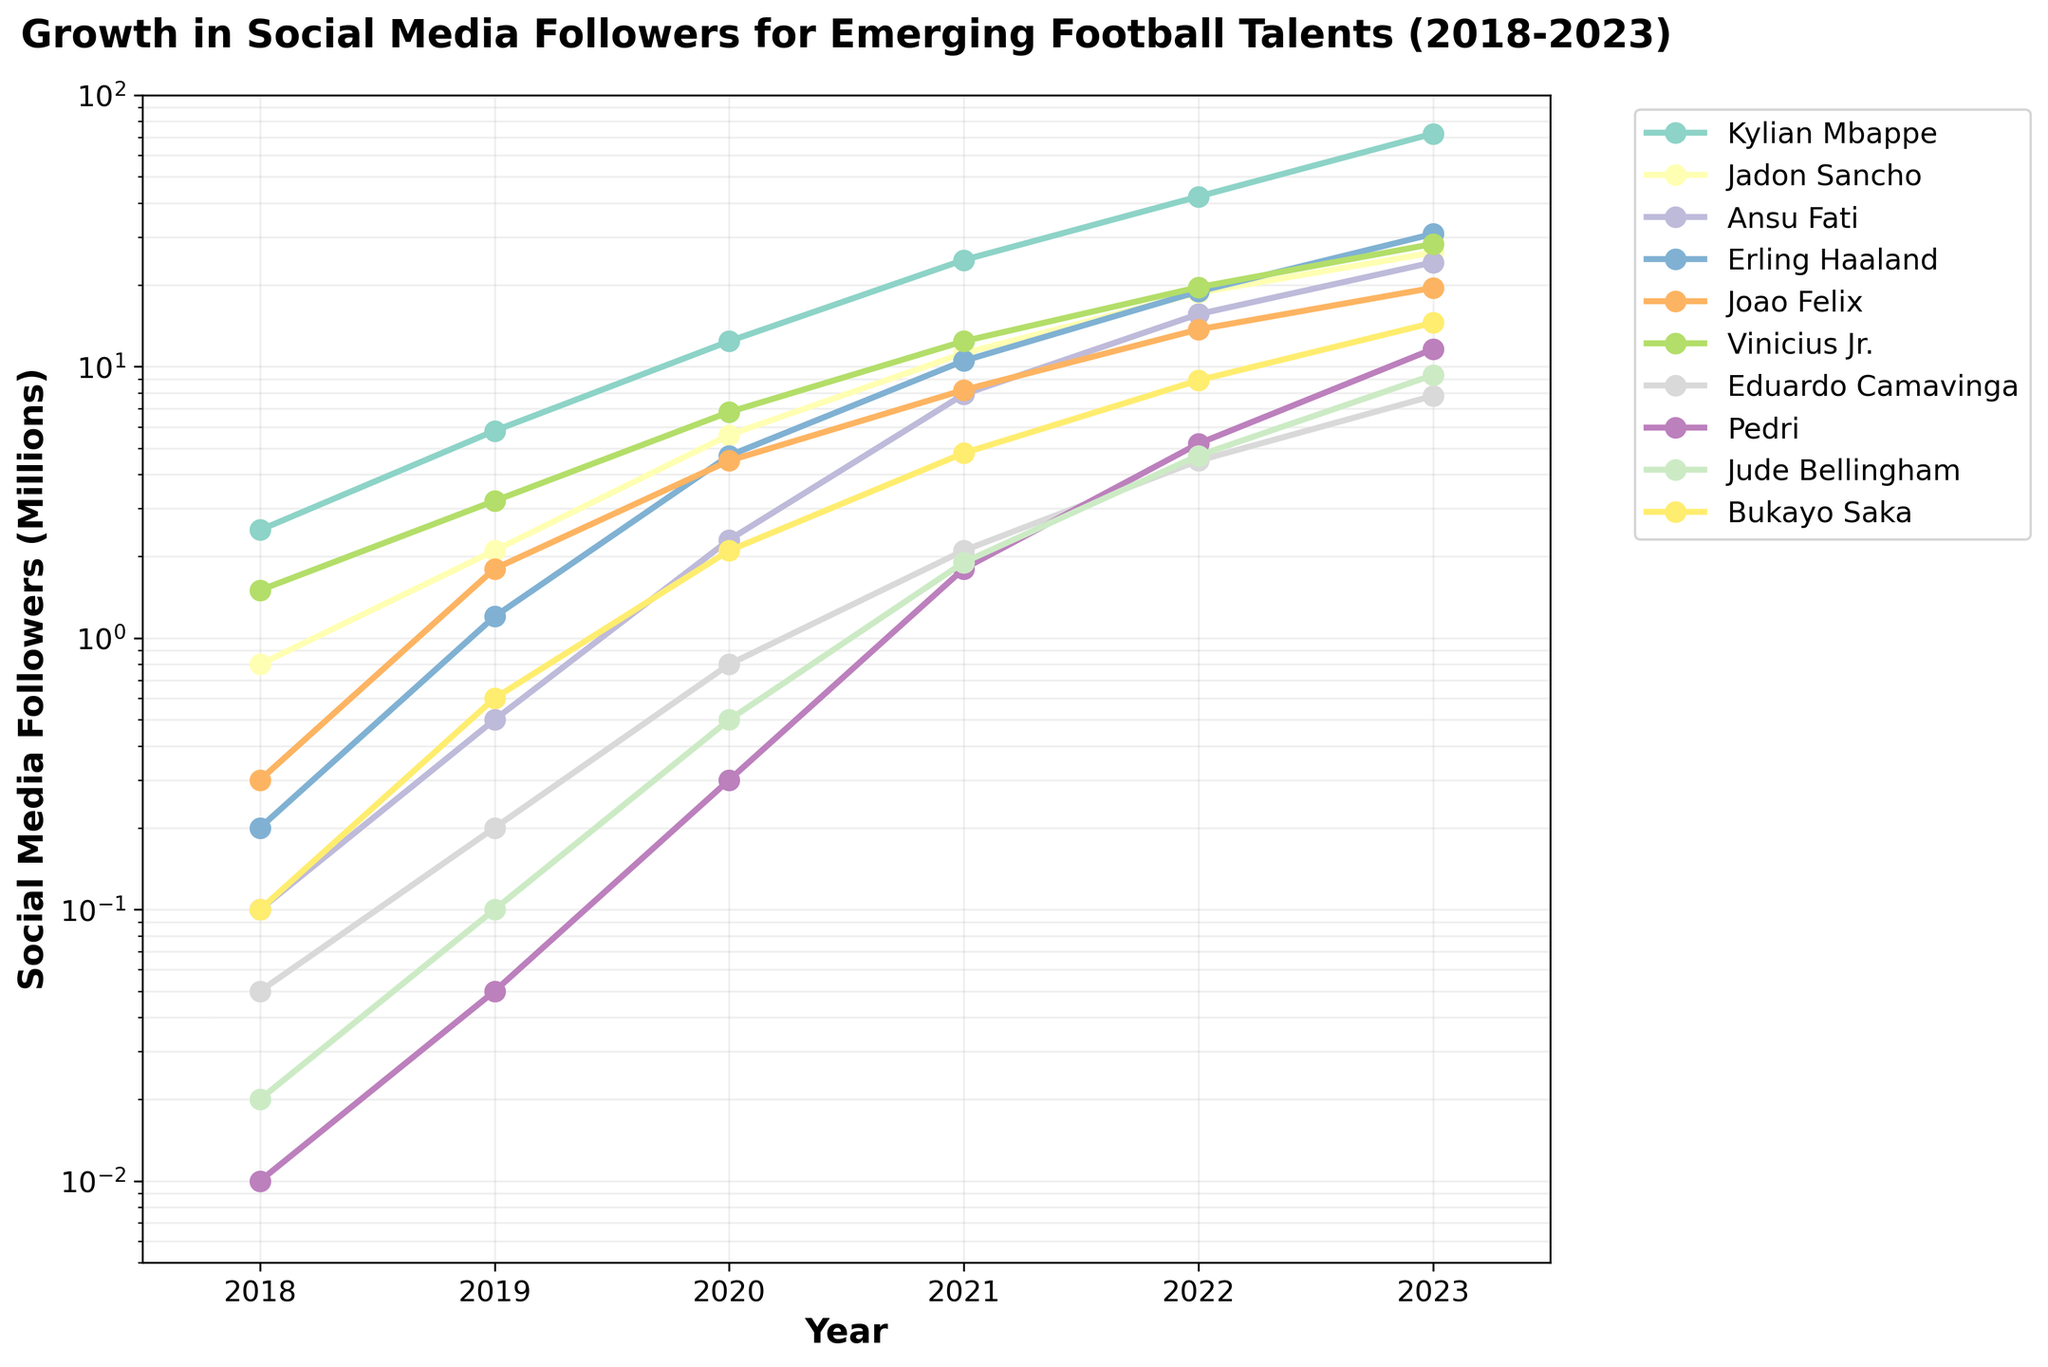What year did Kylian Mbappe's social media followers exceed 10 million? Look at the line for Kylian Mbappe. His followers exceeded 10 million between 2019 and 2020 as the value in 2020 is 12.4 million.
Answer: 2020 Between which two consecutive years did Jadon Sancho's social media followers grow the most? Assess the changes year by year for Jadon Sancho. The largest growth is from 2019 to 2020, rising from 2.1 million to 5.6 million (an increase of 3.5 million).
Answer: 2019-2020 In 2023, did any player other than Kylian Mbappe and Erling Haaland have more than 20 million followers? Check the 2023 values for all players. Only Ansu Fati had more than 20 million followers besides Kylian Mbappe and Erling Haaland.
Answer: Yes What was the total number of social media followers for Vinicius Jr. across all the years in the dataset? Sum the values for Vinicius Jr. from 2018 to 2023: 1.5 + 3.2 + 6.8 + 12.4 + 19.6 + 28.3 = 71.8 million.
Answer: 71.8 million How many players had their social media followers grow by more than 5 million from 2022 to 2023? Compare the increases between 2022 and 2023 for each player. Mbappe (29.8 million), Sancho (7.6 million), Fati (8.6 million), Haaland (11.9 million), Vinicius Jr. (8.7 million), and Pedri (6.4 million) all had increases exceeding 5 million. There are six such players.
Answer: Six Who had more social media followers in 2019: Eduardo Camavinga or Pedri? Check the 2019 values for both players: Camavinga had 0.2 million, and Pedri had 0.05 million. Thus, Camavinga had more followers.
Answer: Eduardo Camavinga What is the average number of social media followers for Erling Haaland over the five-year period? Sum the values for Erling Haaland from 2018 to 2023 and divide by 6: (0.2 + 1.2 + 4.7 + 10.5 + 18.9 + 30.8) / 6 = 66.3 / 6 = 11.05 million.
Answer: 11.05 million 